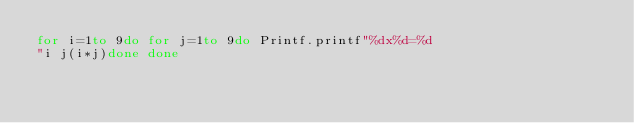Convert code to text. <code><loc_0><loc_0><loc_500><loc_500><_OCaml_>for i=1to 9do for j=1to 9do Printf.printf"%dx%d=%d
"i j(i*j)done done</code> 